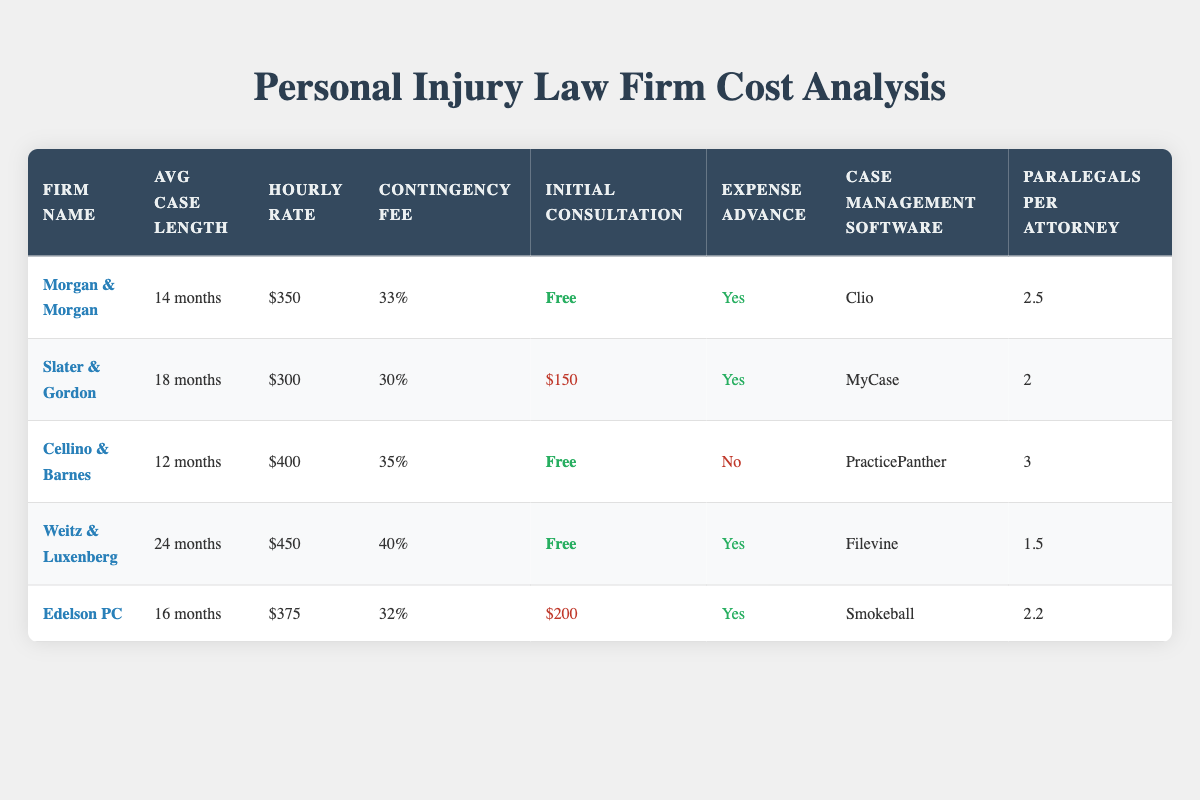What is the average case length among the law firms listed? To find the average case length, we note the case lengths: 14 months, 18 months, 12 months, 24 months, and 16 months. First, we convert the lengths to numbers and sum them: 14 + 18 + 12 + 24 + 16 = 84. Then, we divide by the number of firms (5): 84/5 = 16.8. Thus, the average is approximately 16.8 months.
Answer: 16.8 months Which firm charges the highest hourly rate? From the table, the hourly rates are as follows: Morgan & Morgan ($350), Slater & Gordon ($300), Cellino & Barnes ($400), Weitz & Luxenberg ($450), and Edelson PC ($375). We compare these values and find that Weitz & Luxenberg, with an hourly rate of $450, has the highest rate.
Answer: Weitz & Luxenberg How long does Cellino & Barnes take on average for cases? According to the table, Cellino & Barnes has an average case length of 12 months. It is explicitly stated in the data for that firm.
Answer: 12 months Is there any law firm that does not charge an initial consultation fee? By reviewing the initial consultation fees listed, we find that Morgan & Morgan, Cellino & Barnes, and Weitz & Luxenberg all offer a free initial consultation, while Slater & Gordon and Edelson PC charge $150 and $200, respectively. Therefore, yes, there are firms that do not charge.
Answer: Yes Which law firm has the most paralegals per attorney and what is their value? The number of paralegals per attorney for each firm is as follows: Morgan & Morgan (2.5), Slater & Gordon (2), Cellino & Barnes (3), Weitz & Luxenberg (1.5), and Edelson PC (2.2). Among these, Cellino & Barnes has the highest number, which is 3 paralegals per attorney.
Answer: Cellino & Barnes, 3 How much less does Slater & Gordon charge compared to Weitz & Luxenberg in terms of hourly rate? The hourly rates are as follows: Slater & Gordon charges $300 and Weitz & Luxenberg charges $450. To find the difference, we subtract Slater & Gordon's rate from Weitz & Luxenberg's: $450 - $300 = $150. Thus, Slater & Gordon charges $150 less.
Answer: $150 Does any of the firms advance expenses? Looking at the expense advance column, we see that Morgan & Morgan, Slater & Gordon, Weitz & Luxenberg, and Edelson PC indicate "Yes" for expense advance, while Cellino & Barnes indicates "No." Thus, some firms do advance expenses.
Answer: Yes What is the average contingency fee percentage across the firms? The contingency fees are 33%, 30%, 35%, 40%, and 32% for each firm, respectively. To find the average, we sum these values: 33 + 30 + 35 + 40 + 32 = 170, and then divide by the number of firms: 170/5 = 34%. Therefore, the average contingency fee is 34%.
Answer: 34% 